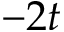Convert formula to latex. <formula><loc_0><loc_0><loc_500><loc_500>- 2 t</formula> 